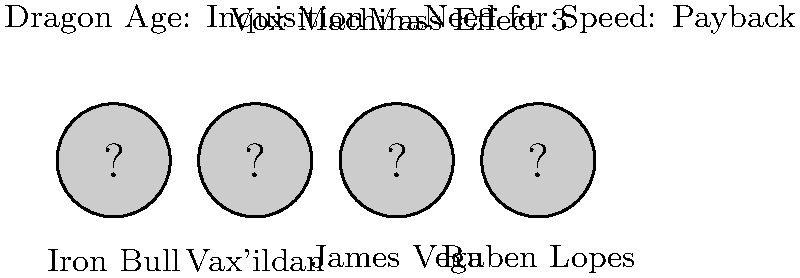Which of the characters shown above was NOT voiced by Freddie Prinze Jr. in the respective video game? To answer this question, we need to go through each character and game:

1. Iron Bull in Dragon Age: Inquisition - Freddie Prinze Jr. did voice this character.
2. Vax'ildan in Vox Machina - This character was voiced by Liam O'Brien, not Freddie Prinze Jr.
3. James Vega in Mass Effect 3 - Freddie Prinze Jr. did voice this character.
4. Ruben Lopes in Need for Speed: Payback - Freddie Prinze Jr. did voice this character.

By process of elimination, we can determine that Vax'ildan is the only character in this lineup not voiced by Freddie Prinze Jr.
Answer: Vax'ildan 